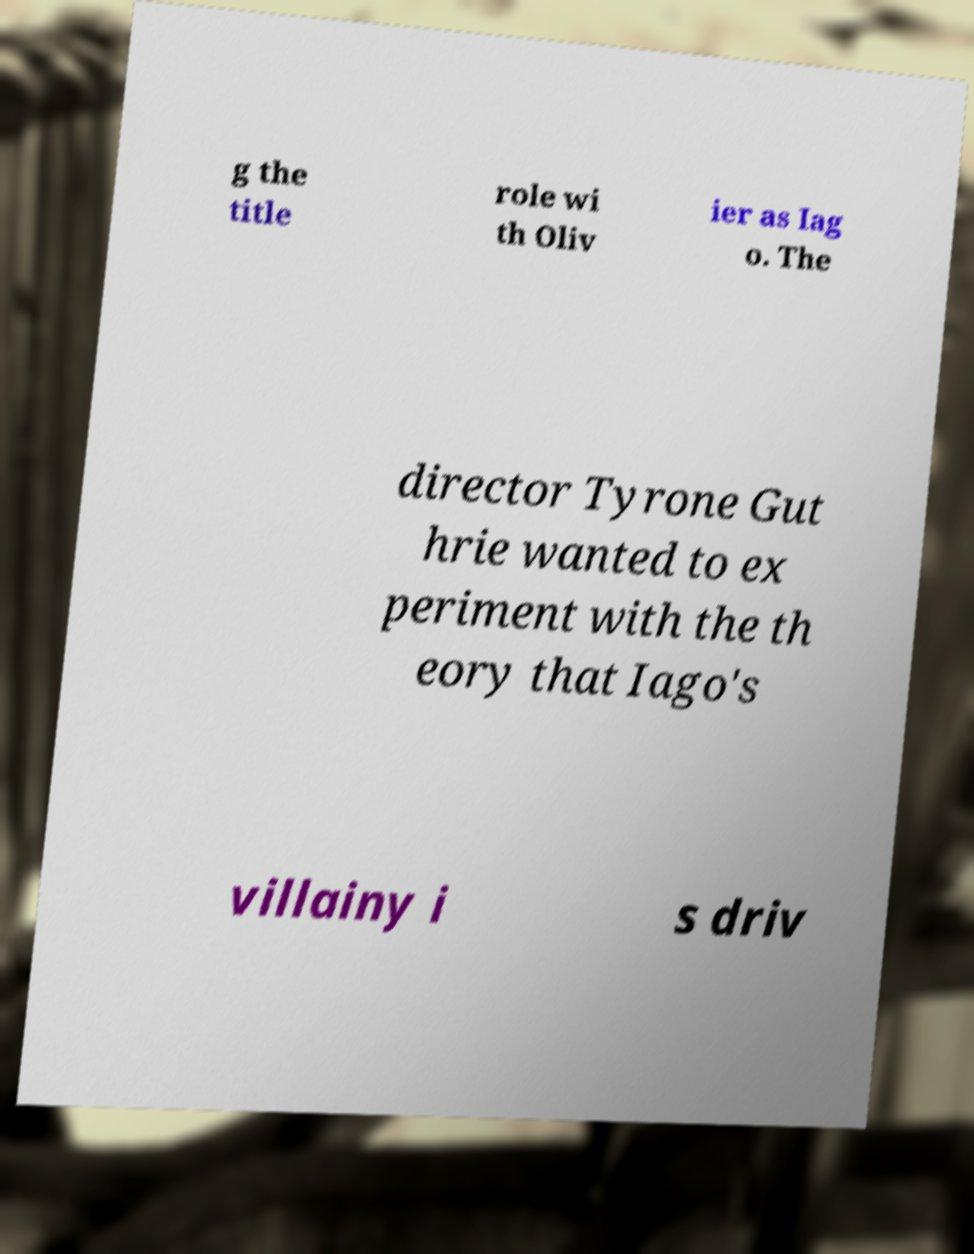What messages or text are displayed in this image? I need them in a readable, typed format. g the title role wi th Oliv ier as Iag o. The director Tyrone Gut hrie wanted to ex periment with the th eory that Iago's villainy i s driv 